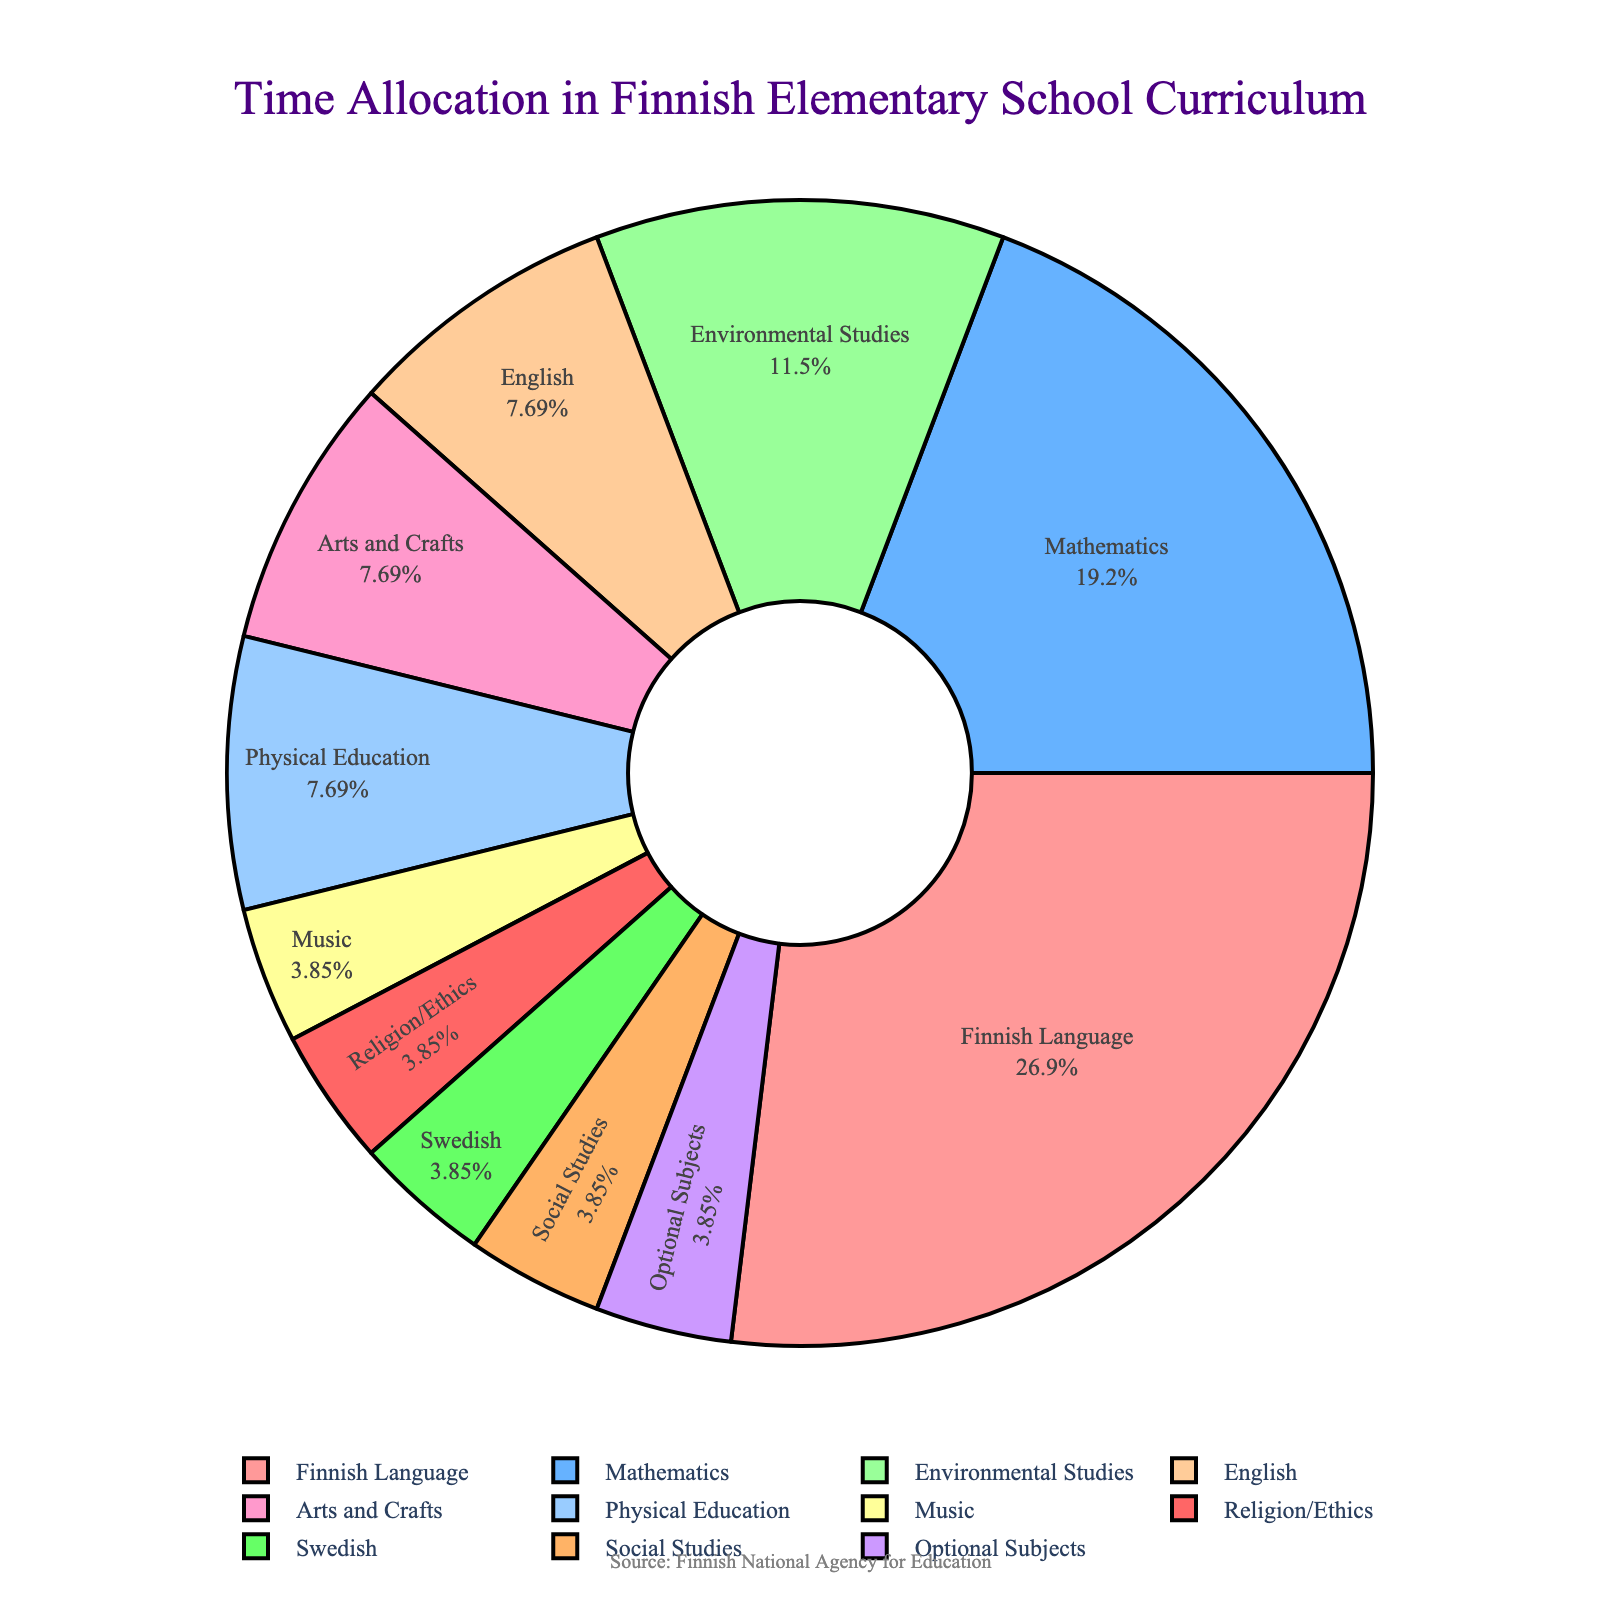What is the percentage of time allocated to Finnish Language? The figure shows a pie chart with the percentage labels for each subject. According to the chart, Finnish Language has a label showing its percentage share.
Answer: 35% Which two subjects together take the most time after Finnish Language? To find this, we look at the pie chart and identify the two subjects with the next highest percentages after Finnish Language. These are likely Mathematics and Environmental Studies.
Answer: Mathematics and Environmental Studies What is the total number of hours per week allocated to Arts and Crafts, Music, and Physical Education? The pie chart provides the hours per week for each subject. Add the hours for Arts and Crafts (2), Music (1), and Physical Education (2). 2+1+2 = 5 hours
Answer: 5 hours How does the time allocated to English compare with the time allocated to Swedish? The figure indicates that English has more allocated hours (2) compared to Swedish (1).
Answer: English has more allocated hours What is the sum of the time allocated to all subjects except Finnish Language? By adding the hours for all other subjects: 5 (Mathematics) + 3 (Environmental Studies) + 2 (English) + 2 (Arts and Crafts) + 2 (Physical Education) + 1 (Music) + 1 (Religion/Ethics) + 1 (Swedish) + 1 (Social Studies) + 1 (Optional Subjects) = 19
Answer: 19 hours Which subject has the smallest allocation of hours? Based on the pie chart, multiple subjects have 1 hour allocated per week. Therefore, the smallest allocation is 1 hour.
Answer: Music, Religion/Ethics, Swedish, Social Studies, Optional Subjects What percentage of time is allocated to Mathematics compared to the total time for all subjects? The total number of hours is 26 (7+5+3+2+2+2+1+1+1+1+1). The percentage for Mathematics is (5/26)*100 ≈ 19.23%.
Answer: approximately 19.23% If you combine the hours for Finnish Language and Mathematics, what fraction of the total weekly hours do they represent together? Adding the hours for Finnish Language (7) and Mathematics (5) gives 12. The total is 26 hours, so the fraction is 12/26 = 6/13.
Answer: 6/13 Which subjects have an equal allocation of hours per week? The figure shows that English, Arts and Crafts, and Physical Education all have 2 hours allocated per week each. Music, Religion/Ethics, Swedish, Social Studies, and Optional Subjects each have 1 hour.
Answer: English, Arts and Crafts, Physical Education (2 hours each); Music, Religion/Ethics, Swedish, Social Studies, Optional Subjects (1 hour each) How does the allocation for Environmental Studies compare to the combined allocation for Music and Religion/Ethics? Environmental Studies is allocated 3 hours, while Music and Religion/Ethics combined is 1+1 = 2 hours.
Answer: Environmental Studies has more allocated hours 